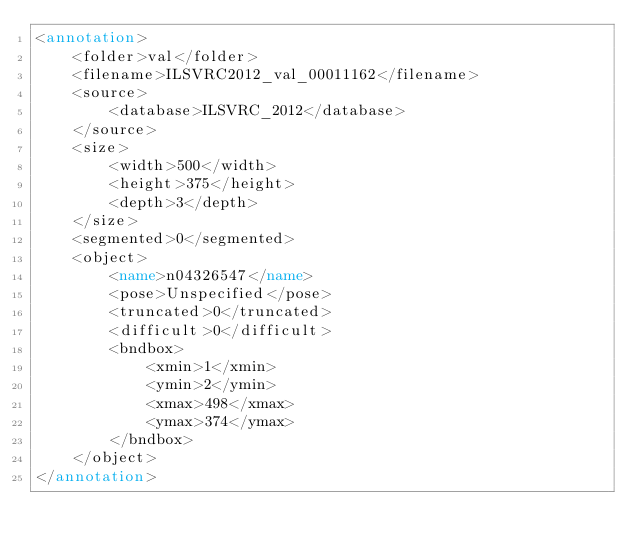<code> <loc_0><loc_0><loc_500><loc_500><_XML_><annotation>
	<folder>val</folder>
	<filename>ILSVRC2012_val_00011162</filename>
	<source>
		<database>ILSVRC_2012</database>
	</source>
	<size>
		<width>500</width>
		<height>375</height>
		<depth>3</depth>
	</size>
	<segmented>0</segmented>
	<object>
		<name>n04326547</name>
		<pose>Unspecified</pose>
		<truncated>0</truncated>
		<difficult>0</difficult>
		<bndbox>
			<xmin>1</xmin>
			<ymin>2</ymin>
			<xmax>498</xmax>
			<ymax>374</ymax>
		</bndbox>
	</object>
</annotation></code> 